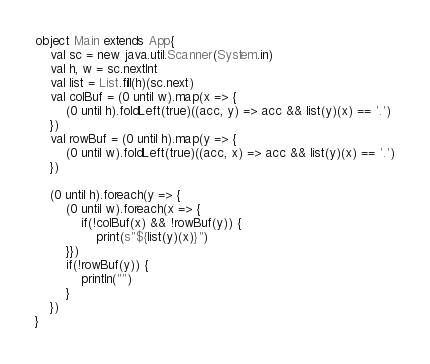<code> <loc_0><loc_0><loc_500><loc_500><_Scala_>object Main extends App{
    val sc = new java.util.Scanner(System.in)
    val h, w = sc.nextInt
    val list = List.fill(h)(sc.next)
    val colBuf = (0 until w).map(x => {
        (0 until h).foldLeft(true)((acc, y) => acc && list(y)(x) == '.')
    })
    val rowBuf = (0 until h).map(y => {
        (0 until w).foldLeft(true)((acc, x) => acc && list(y)(x) == '.')
    })

    (0 until h).foreach(y => {
        (0 until w).foreach(x => {
            if(!colBuf(x) && !rowBuf(y)) {
                print(s"${list(y)(x)}")
        }})
        if(!rowBuf(y)) {
            println("")
        }
    })
}
</code> 